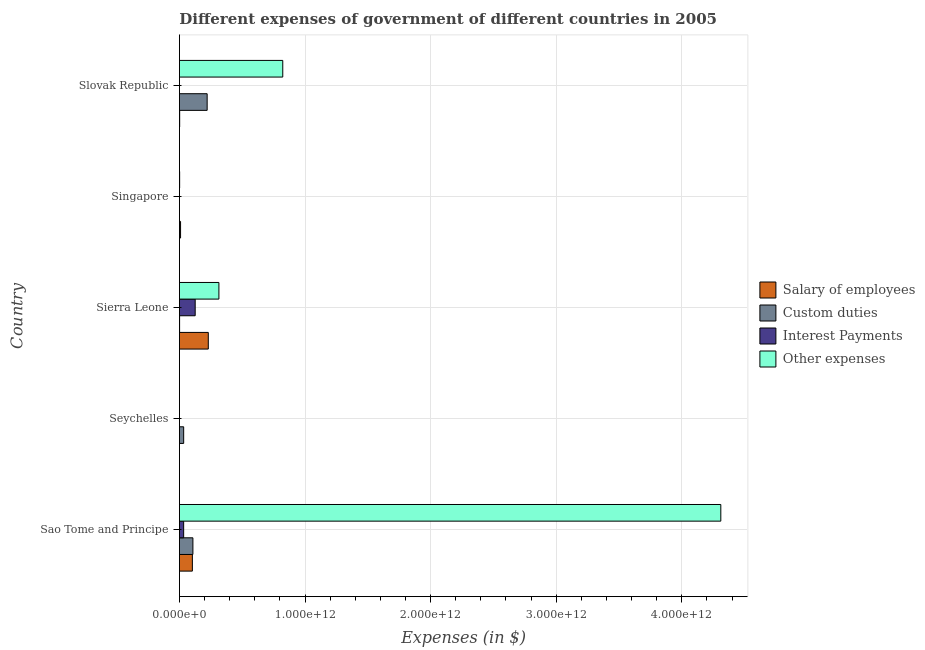How many groups of bars are there?
Offer a terse response. 5. Are the number of bars on each tick of the Y-axis equal?
Give a very brief answer. Yes. How many bars are there on the 1st tick from the top?
Provide a succinct answer. 4. How many bars are there on the 3rd tick from the bottom?
Ensure brevity in your answer.  4. What is the label of the 3rd group of bars from the top?
Offer a terse response. Sierra Leone. What is the amount spent on custom duties in Slovak Republic?
Your response must be concise. 2.21e+11. Across all countries, what is the maximum amount spent on custom duties?
Make the answer very short. 2.21e+11. Across all countries, what is the minimum amount spent on other expenses?
Give a very brief answer. 4.33e+08. In which country was the amount spent on salary of employees maximum?
Provide a succinct answer. Sierra Leone. In which country was the amount spent on interest payments minimum?
Keep it short and to the point. Singapore. What is the total amount spent on interest payments in the graph?
Ensure brevity in your answer.  1.60e+11. What is the difference between the amount spent on interest payments in Seychelles and that in Sierra Leone?
Ensure brevity in your answer.  -1.25e+11. What is the difference between the amount spent on other expenses in Sao Tome and Principe and the amount spent on custom duties in Sierra Leone?
Offer a very short reply. 4.31e+12. What is the average amount spent on salary of employees per country?
Make the answer very short. 6.90e+1. What is the difference between the amount spent on interest payments and amount spent on custom duties in Slovak Republic?
Provide a succinct answer. -2.20e+11. In how many countries, is the amount spent on salary of employees greater than 2200000000000 $?
Provide a succinct answer. 0. What is the ratio of the amount spent on custom duties in Sao Tome and Principe to that in Seychelles?
Offer a very short reply. 3.17. Is the amount spent on interest payments in Sierra Leone less than that in Singapore?
Your response must be concise. No. What is the difference between the highest and the second highest amount spent on other expenses?
Offer a terse response. 3.49e+12. What is the difference between the highest and the lowest amount spent on custom duties?
Keep it short and to the point. 2.20e+11. Is it the case that in every country, the sum of the amount spent on custom duties and amount spent on interest payments is greater than the sum of amount spent on salary of employees and amount spent on other expenses?
Offer a terse response. No. What does the 2nd bar from the top in Sao Tome and Principe represents?
Your answer should be very brief. Interest Payments. What does the 2nd bar from the bottom in Singapore represents?
Offer a very short reply. Custom duties. How many bars are there?
Your answer should be compact. 20. Are all the bars in the graph horizontal?
Your answer should be compact. Yes. How many countries are there in the graph?
Your answer should be very brief. 5. What is the difference between two consecutive major ticks on the X-axis?
Your response must be concise. 1.00e+12. Are the values on the major ticks of X-axis written in scientific E-notation?
Give a very brief answer. Yes. What is the title of the graph?
Provide a succinct answer. Different expenses of government of different countries in 2005. What is the label or title of the X-axis?
Provide a succinct answer. Expenses (in $). What is the Expenses (in $) of Salary of employees in Sao Tome and Principe?
Your answer should be compact. 1.03e+11. What is the Expenses (in $) of Custom duties in Sao Tome and Principe?
Your response must be concise. 1.07e+11. What is the Expenses (in $) of Interest Payments in Sao Tome and Principe?
Offer a terse response. 3.37e+1. What is the Expenses (in $) in Other expenses in Sao Tome and Principe?
Your answer should be very brief. 4.31e+12. What is the Expenses (in $) of Salary of employees in Seychelles?
Your answer should be very brief. 6.81e+08. What is the Expenses (in $) of Custom duties in Seychelles?
Provide a short and direct response. 3.39e+1. What is the Expenses (in $) in Interest Payments in Seychelles?
Make the answer very short. 2.60e+08. What is the Expenses (in $) of Other expenses in Seychelles?
Give a very brief answer. 4.33e+08. What is the Expenses (in $) in Salary of employees in Sierra Leone?
Give a very brief answer. 2.30e+11. What is the Expenses (in $) in Custom duties in Sierra Leone?
Your answer should be compact. 1.47e+09. What is the Expenses (in $) of Interest Payments in Sierra Leone?
Your answer should be compact. 1.26e+11. What is the Expenses (in $) of Other expenses in Sierra Leone?
Provide a succinct answer. 3.14e+11. What is the Expenses (in $) of Salary of employees in Singapore?
Offer a very short reply. 9.11e+09. What is the Expenses (in $) in Custom duties in Singapore?
Your answer should be very brief. 7.28e+08. What is the Expenses (in $) of Interest Payments in Singapore?
Your answer should be compact. 2.03e+08. What is the Expenses (in $) in Other expenses in Singapore?
Provide a short and direct response. 1.83e+09. What is the Expenses (in $) of Salary of employees in Slovak Republic?
Your answer should be compact. 2.10e+09. What is the Expenses (in $) in Custom duties in Slovak Republic?
Make the answer very short. 2.21e+11. What is the Expenses (in $) of Interest Payments in Slovak Republic?
Give a very brief answer. 7.00e+08. What is the Expenses (in $) of Other expenses in Slovak Republic?
Offer a terse response. 8.23e+11. Across all countries, what is the maximum Expenses (in $) in Salary of employees?
Offer a terse response. 2.30e+11. Across all countries, what is the maximum Expenses (in $) of Custom duties?
Make the answer very short. 2.21e+11. Across all countries, what is the maximum Expenses (in $) of Interest Payments?
Offer a terse response. 1.26e+11. Across all countries, what is the maximum Expenses (in $) in Other expenses?
Your response must be concise. 4.31e+12. Across all countries, what is the minimum Expenses (in $) of Salary of employees?
Keep it short and to the point. 6.81e+08. Across all countries, what is the minimum Expenses (in $) in Custom duties?
Your answer should be compact. 7.28e+08. Across all countries, what is the minimum Expenses (in $) of Interest Payments?
Give a very brief answer. 2.03e+08. Across all countries, what is the minimum Expenses (in $) of Other expenses?
Offer a very short reply. 4.33e+08. What is the total Expenses (in $) in Salary of employees in the graph?
Offer a terse response. 3.45e+11. What is the total Expenses (in $) of Custom duties in the graph?
Offer a very short reply. 3.64e+11. What is the total Expenses (in $) of Interest Payments in the graph?
Keep it short and to the point. 1.60e+11. What is the total Expenses (in $) in Other expenses in the graph?
Keep it short and to the point. 5.45e+12. What is the difference between the Expenses (in $) of Salary of employees in Sao Tome and Principe and that in Seychelles?
Provide a short and direct response. 1.03e+11. What is the difference between the Expenses (in $) in Custom duties in Sao Tome and Principe and that in Seychelles?
Give a very brief answer. 7.35e+1. What is the difference between the Expenses (in $) in Interest Payments in Sao Tome and Principe and that in Seychelles?
Offer a very short reply. 3.35e+1. What is the difference between the Expenses (in $) in Other expenses in Sao Tome and Principe and that in Seychelles?
Your answer should be compact. 4.31e+12. What is the difference between the Expenses (in $) of Salary of employees in Sao Tome and Principe and that in Sierra Leone?
Make the answer very short. -1.27e+11. What is the difference between the Expenses (in $) of Custom duties in Sao Tome and Principe and that in Sierra Leone?
Provide a succinct answer. 1.06e+11. What is the difference between the Expenses (in $) of Interest Payments in Sao Tome and Principe and that in Sierra Leone?
Your answer should be very brief. -9.19e+1. What is the difference between the Expenses (in $) in Other expenses in Sao Tome and Principe and that in Sierra Leone?
Offer a terse response. 4.00e+12. What is the difference between the Expenses (in $) of Salary of employees in Sao Tome and Principe and that in Singapore?
Your answer should be compact. 9.41e+1. What is the difference between the Expenses (in $) of Custom duties in Sao Tome and Principe and that in Singapore?
Your answer should be very brief. 1.07e+11. What is the difference between the Expenses (in $) of Interest Payments in Sao Tome and Principe and that in Singapore?
Provide a succinct answer. 3.35e+1. What is the difference between the Expenses (in $) in Other expenses in Sao Tome and Principe and that in Singapore?
Your answer should be very brief. 4.31e+12. What is the difference between the Expenses (in $) of Salary of employees in Sao Tome and Principe and that in Slovak Republic?
Your answer should be very brief. 1.01e+11. What is the difference between the Expenses (in $) in Custom duties in Sao Tome and Principe and that in Slovak Republic?
Keep it short and to the point. -1.13e+11. What is the difference between the Expenses (in $) of Interest Payments in Sao Tome and Principe and that in Slovak Republic?
Make the answer very short. 3.30e+1. What is the difference between the Expenses (in $) in Other expenses in Sao Tome and Principe and that in Slovak Republic?
Your answer should be very brief. 3.49e+12. What is the difference between the Expenses (in $) of Salary of employees in Seychelles and that in Sierra Leone?
Offer a terse response. -2.29e+11. What is the difference between the Expenses (in $) of Custom duties in Seychelles and that in Sierra Leone?
Your response must be concise. 3.24e+1. What is the difference between the Expenses (in $) of Interest Payments in Seychelles and that in Sierra Leone?
Offer a terse response. -1.25e+11. What is the difference between the Expenses (in $) of Other expenses in Seychelles and that in Sierra Leone?
Provide a succinct answer. -3.14e+11. What is the difference between the Expenses (in $) in Salary of employees in Seychelles and that in Singapore?
Your answer should be very brief. -8.43e+09. What is the difference between the Expenses (in $) in Custom duties in Seychelles and that in Singapore?
Offer a terse response. 3.32e+1. What is the difference between the Expenses (in $) in Interest Payments in Seychelles and that in Singapore?
Offer a very short reply. 5.73e+07. What is the difference between the Expenses (in $) of Other expenses in Seychelles and that in Singapore?
Make the answer very short. -1.40e+09. What is the difference between the Expenses (in $) of Salary of employees in Seychelles and that in Slovak Republic?
Your response must be concise. -1.42e+09. What is the difference between the Expenses (in $) in Custom duties in Seychelles and that in Slovak Republic?
Your response must be concise. -1.87e+11. What is the difference between the Expenses (in $) in Interest Payments in Seychelles and that in Slovak Republic?
Make the answer very short. -4.40e+08. What is the difference between the Expenses (in $) in Other expenses in Seychelles and that in Slovak Republic?
Offer a very short reply. -8.23e+11. What is the difference between the Expenses (in $) in Salary of employees in Sierra Leone and that in Singapore?
Offer a very short reply. 2.21e+11. What is the difference between the Expenses (in $) in Custom duties in Sierra Leone and that in Singapore?
Provide a succinct answer. 7.46e+08. What is the difference between the Expenses (in $) in Interest Payments in Sierra Leone and that in Singapore?
Keep it short and to the point. 1.25e+11. What is the difference between the Expenses (in $) in Other expenses in Sierra Leone and that in Singapore?
Your answer should be very brief. 3.13e+11. What is the difference between the Expenses (in $) in Salary of employees in Sierra Leone and that in Slovak Republic?
Ensure brevity in your answer.  2.28e+11. What is the difference between the Expenses (in $) in Custom duties in Sierra Leone and that in Slovak Republic?
Ensure brevity in your answer.  -2.19e+11. What is the difference between the Expenses (in $) of Interest Payments in Sierra Leone and that in Slovak Republic?
Ensure brevity in your answer.  1.25e+11. What is the difference between the Expenses (in $) of Other expenses in Sierra Leone and that in Slovak Republic?
Provide a short and direct response. -5.09e+11. What is the difference between the Expenses (in $) of Salary of employees in Singapore and that in Slovak Republic?
Offer a terse response. 7.01e+09. What is the difference between the Expenses (in $) of Custom duties in Singapore and that in Slovak Republic?
Your answer should be very brief. -2.20e+11. What is the difference between the Expenses (in $) of Interest Payments in Singapore and that in Slovak Republic?
Give a very brief answer. -4.97e+08. What is the difference between the Expenses (in $) in Other expenses in Singapore and that in Slovak Republic?
Provide a short and direct response. -8.21e+11. What is the difference between the Expenses (in $) in Salary of employees in Sao Tome and Principe and the Expenses (in $) in Custom duties in Seychelles?
Your answer should be very brief. 6.93e+1. What is the difference between the Expenses (in $) in Salary of employees in Sao Tome and Principe and the Expenses (in $) in Interest Payments in Seychelles?
Offer a terse response. 1.03e+11. What is the difference between the Expenses (in $) in Salary of employees in Sao Tome and Principe and the Expenses (in $) in Other expenses in Seychelles?
Your answer should be very brief. 1.03e+11. What is the difference between the Expenses (in $) of Custom duties in Sao Tome and Principe and the Expenses (in $) of Interest Payments in Seychelles?
Provide a short and direct response. 1.07e+11. What is the difference between the Expenses (in $) of Custom duties in Sao Tome and Principe and the Expenses (in $) of Other expenses in Seychelles?
Offer a terse response. 1.07e+11. What is the difference between the Expenses (in $) in Interest Payments in Sao Tome and Principe and the Expenses (in $) in Other expenses in Seychelles?
Your response must be concise. 3.33e+1. What is the difference between the Expenses (in $) in Salary of employees in Sao Tome and Principe and the Expenses (in $) in Custom duties in Sierra Leone?
Make the answer very short. 1.02e+11. What is the difference between the Expenses (in $) in Salary of employees in Sao Tome and Principe and the Expenses (in $) in Interest Payments in Sierra Leone?
Give a very brief answer. -2.24e+1. What is the difference between the Expenses (in $) of Salary of employees in Sao Tome and Principe and the Expenses (in $) of Other expenses in Sierra Leone?
Offer a terse response. -2.11e+11. What is the difference between the Expenses (in $) of Custom duties in Sao Tome and Principe and the Expenses (in $) of Interest Payments in Sierra Leone?
Your answer should be compact. -1.82e+1. What is the difference between the Expenses (in $) of Custom duties in Sao Tome and Principe and the Expenses (in $) of Other expenses in Sierra Leone?
Your answer should be very brief. -2.07e+11. What is the difference between the Expenses (in $) in Interest Payments in Sao Tome and Principe and the Expenses (in $) in Other expenses in Sierra Leone?
Offer a terse response. -2.81e+11. What is the difference between the Expenses (in $) of Salary of employees in Sao Tome and Principe and the Expenses (in $) of Custom duties in Singapore?
Ensure brevity in your answer.  1.02e+11. What is the difference between the Expenses (in $) of Salary of employees in Sao Tome and Principe and the Expenses (in $) of Interest Payments in Singapore?
Provide a short and direct response. 1.03e+11. What is the difference between the Expenses (in $) of Salary of employees in Sao Tome and Principe and the Expenses (in $) of Other expenses in Singapore?
Your answer should be very brief. 1.01e+11. What is the difference between the Expenses (in $) in Custom duties in Sao Tome and Principe and the Expenses (in $) in Interest Payments in Singapore?
Provide a short and direct response. 1.07e+11. What is the difference between the Expenses (in $) in Custom duties in Sao Tome and Principe and the Expenses (in $) in Other expenses in Singapore?
Give a very brief answer. 1.06e+11. What is the difference between the Expenses (in $) in Interest Payments in Sao Tome and Principe and the Expenses (in $) in Other expenses in Singapore?
Give a very brief answer. 3.19e+1. What is the difference between the Expenses (in $) in Salary of employees in Sao Tome and Principe and the Expenses (in $) in Custom duties in Slovak Republic?
Provide a short and direct response. -1.18e+11. What is the difference between the Expenses (in $) of Salary of employees in Sao Tome and Principe and the Expenses (in $) of Interest Payments in Slovak Republic?
Ensure brevity in your answer.  1.03e+11. What is the difference between the Expenses (in $) in Salary of employees in Sao Tome and Principe and the Expenses (in $) in Other expenses in Slovak Republic?
Offer a terse response. -7.20e+11. What is the difference between the Expenses (in $) of Custom duties in Sao Tome and Principe and the Expenses (in $) of Interest Payments in Slovak Republic?
Offer a very short reply. 1.07e+11. What is the difference between the Expenses (in $) of Custom duties in Sao Tome and Principe and the Expenses (in $) of Other expenses in Slovak Republic?
Offer a terse response. -7.16e+11. What is the difference between the Expenses (in $) of Interest Payments in Sao Tome and Principe and the Expenses (in $) of Other expenses in Slovak Republic?
Offer a terse response. -7.89e+11. What is the difference between the Expenses (in $) of Salary of employees in Seychelles and the Expenses (in $) of Custom duties in Sierra Leone?
Your response must be concise. -7.93e+08. What is the difference between the Expenses (in $) in Salary of employees in Seychelles and the Expenses (in $) in Interest Payments in Sierra Leone?
Provide a short and direct response. -1.25e+11. What is the difference between the Expenses (in $) of Salary of employees in Seychelles and the Expenses (in $) of Other expenses in Sierra Leone?
Your answer should be very brief. -3.14e+11. What is the difference between the Expenses (in $) of Custom duties in Seychelles and the Expenses (in $) of Interest Payments in Sierra Leone?
Make the answer very short. -9.17e+1. What is the difference between the Expenses (in $) of Custom duties in Seychelles and the Expenses (in $) of Other expenses in Sierra Leone?
Offer a terse response. -2.81e+11. What is the difference between the Expenses (in $) of Interest Payments in Seychelles and the Expenses (in $) of Other expenses in Sierra Leone?
Provide a short and direct response. -3.14e+11. What is the difference between the Expenses (in $) of Salary of employees in Seychelles and the Expenses (in $) of Custom duties in Singapore?
Make the answer very short. -4.69e+07. What is the difference between the Expenses (in $) in Salary of employees in Seychelles and the Expenses (in $) in Interest Payments in Singapore?
Provide a short and direct response. 4.78e+08. What is the difference between the Expenses (in $) of Salary of employees in Seychelles and the Expenses (in $) of Other expenses in Singapore?
Your response must be concise. -1.15e+09. What is the difference between the Expenses (in $) of Custom duties in Seychelles and the Expenses (in $) of Interest Payments in Singapore?
Give a very brief answer. 3.37e+1. What is the difference between the Expenses (in $) in Custom duties in Seychelles and the Expenses (in $) in Other expenses in Singapore?
Your response must be concise. 3.20e+1. What is the difference between the Expenses (in $) of Interest Payments in Seychelles and the Expenses (in $) of Other expenses in Singapore?
Provide a short and direct response. -1.57e+09. What is the difference between the Expenses (in $) of Salary of employees in Seychelles and the Expenses (in $) of Custom duties in Slovak Republic?
Give a very brief answer. -2.20e+11. What is the difference between the Expenses (in $) of Salary of employees in Seychelles and the Expenses (in $) of Interest Payments in Slovak Republic?
Offer a terse response. -1.92e+07. What is the difference between the Expenses (in $) in Salary of employees in Seychelles and the Expenses (in $) in Other expenses in Slovak Republic?
Offer a very short reply. -8.22e+11. What is the difference between the Expenses (in $) of Custom duties in Seychelles and the Expenses (in $) of Interest Payments in Slovak Republic?
Give a very brief answer. 3.32e+1. What is the difference between the Expenses (in $) in Custom duties in Seychelles and the Expenses (in $) in Other expenses in Slovak Republic?
Your answer should be very brief. -7.89e+11. What is the difference between the Expenses (in $) of Interest Payments in Seychelles and the Expenses (in $) of Other expenses in Slovak Republic?
Offer a terse response. -8.23e+11. What is the difference between the Expenses (in $) in Salary of employees in Sierra Leone and the Expenses (in $) in Custom duties in Singapore?
Your answer should be very brief. 2.29e+11. What is the difference between the Expenses (in $) of Salary of employees in Sierra Leone and the Expenses (in $) of Interest Payments in Singapore?
Your response must be concise. 2.30e+11. What is the difference between the Expenses (in $) in Salary of employees in Sierra Leone and the Expenses (in $) in Other expenses in Singapore?
Your answer should be compact. 2.28e+11. What is the difference between the Expenses (in $) in Custom duties in Sierra Leone and the Expenses (in $) in Interest Payments in Singapore?
Keep it short and to the point. 1.27e+09. What is the difference between the Expenses (in $) of Custom duties in Sierra Leone and the Expenses (in $) of Other expenses in Singapore?
Your answer should be compact. -3.60e+08. What is the difference between the Expenses (in $) in Interest Payments in Sierra Leone and the Expenses (in $) in Other expenses in Singapore?
Ensure brevity in your answer.  1.24e+11. What is the difference between the Expenses (in $) of Salary of employees in Sierra Leone and the Expenses (in $) of Custom duties in Slovak Republic?
Keep it short and to the point. 9.07e+09. What is the difference between the Expenses (in $) in Salary of employees in Sierra Leone and the Expenses (in $) in Interest Payments in Slovak Republic?
Ensure brevity in your answer.  2.29e+11. What is the difference between the Expenses (in $) of Salary of employees in Sierra Leone and the Expenses (in $) of Other expenses in Slovak Republic?
Offer a terse response. -5.93e+11. What is the difference between the Expenses (in $) in Custom duties in Sierra Leone and the Expenses (in $) in Interest Payments in Slovak Republic?
Provide a succinct answer. 7.74e+08. What is the difference between the Expenses (in $) of Custom duties in Sierra Leone and the Expenses (in $) of Other expenses in Slovak Republic?
Provide a succinct answer. -8.21e+11. What is the difference between the Expenses (in $) in Interest Payments in Sierra Leone and the Expenses (in $) in Other expenses in Slovak Republic?
Provide a succinct answer. -6.97e+11. What is the difference between the Expenses (in $) in Salary of employees in Singapore and the Expenses (in $) in Custom duties in Slovak Republic?
Offer a very short reply. -2.12e+11. What is the difference between the Expenses (in $) in Salary of employees in Singapore and the Expenses (in $) in Interest Payments in Slovak Republic?
Offer a very short reply. 8.41e+09. What is the difference between the Expenses (in $) of Salary of employees in Singapore and the Expenses (in $) of Other expenses in Slovak Republic?
Offer a terse response. -8.14e+11. What is the difference between the Expenses (in $) in Custom duties in Singapore and the Expenses (in $) in Interest Payments in Slovak Republic?
Provide a short and direct response. 2.78e+07. What is the difference between the Expenses (in $) of Custom duties in Singapore and the Expenses (in $) of Other expenses in Slovak Republic?
Provide a short and direct response. -8.22e+11. What is the difference between the Expenses (in $) of Interest Payments in Singapore and the Expenses (in $) of Other expenses in Slovak Republic?
Keep it short and to the point. -8.23e+11. What is the average Expenses (in $) in Salary of employees per country?
Give a very brief answer. 6.90e+1. What is the average Expenses (in $) in Custom duties per country?
Provide a short and direct response. 7.29e+1. What is the average Expenses (in $) in Interest Payments per country?
Provide a short and direct response. 3.21e+1. What is the average Expenses (in $) of Other expenses per country?
Your answer should be very brief. 1.09e+12. What is the difference between the Expenses (in $) in Salary of employees and Expenses (in $) in Custom duties in Sao Tome and Principe?
Your answer should be very brief. -4.19e+09. What is the difference between the Expenses (in $) in Salary of employees and Expenses (in $) in Interest Payments in Sao Tome and Principe?
Give a very brief answer. 6.95e+1. What is the difference between the Expenses (in $) in Salary of employees and Expenses (in $) in Other expenses in Sao Tome and Principe?
Offer a terse response. -4.21e+12. What is the difference between the Expenses (in $) of Custom duties and Expenses (in $) of Interest Payments in Sao Tome and Principe?
Provide a short and direct response. 7.37e+1. What is the difference between the Expenses (in $) in Custom duties and Expenses (in $) in Other expenses in Sao Tome and Principe?
Make the answer very short. -4.20e+12. What is the difference between the Expenses (in $) in Interest Payments and Expenses (in $) in Other expenses in Sao Tome and Principe?
Give a very brief answer. -4.28e+12. What is the difference between the Expenses (in $) of Salary of employees and Expenses (in $) of Custom duties in Seychelles?
Provide a succinct answer. -3.32e+1. What is the difference between the Expenses (in $) in Salary of employees and Expenses (in $) in Interest Payments in Seychelles?
Make the answer very short. 4.20e+08. What is the difference between the Expenses (in $) in Salary of employees and Expenses (in $) in Other expenses in Seychelles?
Make the answer very short. 2.48e+08. What is the difference between the Expenses (in $) of Custom duties and Expenses (in $) of Interest Payments in Seychelles?
Give a very brief answer. 3.36e+1. What is the difference between the Expenses (in $) of Custom duties and Expenses (in $) of Other expenses in Seychelles?
Give a very brief answer. 3.34e+1. What is the difference between the Expenses (in $) of Interest Payments and Expenses (in $) of Other expenses in Seychelles?
Offer a very short reply. -1.73e+08. What is the difference between the Expenses (in $) of Salary of employees and Expenses (in $) of Custom duties in Sierra Leone?
Provide a succinct answer. 2.28e+11. What is the difference between the Expenses (in $) of Salary of employees and Expenses (in $) of Interest Payments in Sierra Leone?
Offer a very short reply. 1.04e+11. What is the difference between the Expenses (in $) of Salary of employees and Expenses (in $) of Other expenses in Sierra Leone?
Ensure brevity in your answer.  -8.45e+1. What is the difference between the Expenses (in $) of Custom duties and Expenses (in $) of Interest Payments in Sierra Leone?
Make the answer very short. -1.24e+11. What is the difference between the Expenses (in $) of Custom duties and Expenses (in $) of Other expenses in Sierra Leone?
Offer a very short reply. -3.13e+11. What is the difference between the Expenses (in $) of Interest Payments and Expenses (in $) of Other expenses in Sierra Leone?
Provide a short and direct response. -1.89e+11. What is the difference between the Expenses (in $) of Salary of employees and Expenses (in $) of Custom duties in Singapore?
Ensure brevity in your answer.  8.38e+09. What is the difference between the Expenses (in $) in Salary of employees and Expenses (in $) in Interest Payments in Singapore?
Give a very brief answer. 8.91e+09. What is the difference between the Expenses (in $) of Salary of employees and Expenses (in $) of Other expenses in Singapore?
Offer a terse response. 7.28e+09. What is the difference between the Expenses (in $) in Custom duties and Expenses (in $) in Interest Payments in Singapore?
Ensure brevity in your answer.  5.25e+08. What is the difference between the Expenses (in $) of Custom duties and Expenses (in $) of Other expenses in Singapore?
Keep it short and to the point. -1.11e+09. What is the difference between the Expenses (in $) of Interest Payments and Expenses (in $) of Other expenses in Singapore?
Offer a terse response. -1.63e+09. What is the difference between the Expenses (in $) of Salary of employees and Expenses (in $) of Custom duties in Slovak Republic?
Offer a terse response. -2.19e+11. What is the difference between the Expenses (in $) in Salary of employees and Expenses (in $) in Interest Payments in Slovak Republic?
Keep it short and to the point. 1.40e+09. What is the difference between the Expenses (in $) of Salary of employees and Expenses (in $) of Other expenses in Slovak Republic?
Offer a very short reply. -8.21e+11. What is the difference between the Expenses (in $) in Custom duties and Expenses (in $) in Interest Payments in Slovak Republic?
Provide a short and direct response. 2.20e+11. What is the difference between the Expenses (in $) in Custom duties and Expenses (in $) in Other expenses in Slovak Republic?
Provide a succinct answer. -6.02e+11. What is the difference between the Expenses (in $) in Interest Payments and Expenses (in $) in Other expenses in Slovak Republic?
Your answer should be compact. -8.22e+11. What is the ratio of the Expenses (in $) of Salary of employees in Sao Tome and Principe to that in Seychelles?
Your answer should be compact. 151.6. What is the ratio of the Expenses (in $) in Custom duties in Sao Tome and Principe to that in Seychelles?
Make the answer very short. 3.17. What is the ratio of the Expenses (in $) in Interest Payments in Sao Tome and Principe to that in Seychelles?
Provide a succinct answer. 129.56. What is the ratio of the Expenses (in $) in Other expenses in Sao Tome and Principe to that in Seychelles?
Offer a very short reply. 9953.28. What is the ratio of the Expenses (in $) in Salary of employees in Sao Tome and Principe to that in Sierra Leone?
Make the answer very short. 0.45. What is the ratio of the Expenses (in $) of Custom duties in Sao Tome and Principe to that in Sierra Leone?
Provide a short and direct response. 72.88. What is the ratio of the Expenses (in $) in Interest Payments in Sao Tome and Principe to that in Sierra Leone?
Your answer should be compact. 0.27. What is the ratio of the Expenses (in $) of Other expenses in Sao Tome and Principe to that in Sierra Leone?
Offer a very short reply. 13.71. What is the ratio of the Expenses (in $) in Salary of employees in Sao Tome and Principe to that in Singapore?
Offer a very short reply. 11.33. What is the ratio of the Expenses (in $) of Custom duties in Sao Tome and Principe to that in Singapore?
Your answer should be compact. 147.58. What is the ratio of the Expenses (in $) in Interest Payments in Sao Tome and Principe to that in Singapore?
Offer a very short reply. 166.16. What is the ratio of the Expenses (in $) in Other expenses in Sao Tome and Principe to that in Singapore?
Your response must be concise. 2351.23. What is the ratio of the Expenses (in $) of Salary of employees in Sao Tome and Principe to that in Slovak Republic?
Make the answer very short. 49.04. What is the ratio of the Expenses (in $) in Custom duties in Sao Tome and Principe to that in Slovak Republic?
Provide a short and direct response. 0.49. What is the ratio of the Expenses (in $) of Interest Payments in Sao Tome and Principe to that in Slovak Republic?
Give a very brief answer. 48.19. What is the ratio of the Expenses (in $) in Other expenses in Sao Tome and Principe to that in Slovak Republic?
Offer a terse response. 5.24. What is the ratio of the Expenses (in $) of Salary of employees in Seychelles to that in Sierra Leone?
Ensure brevity in your answer.  0. What is the ratio of the Expenses (in $) in Custom duties in Seychelles to that in Sierra Leone?
Make the answer very short. 22.99. What is the ratio of the Expenses (in $) of Interest Payments in Seychelles to that in Sierra Leone?
Make the answer very short. 0. What is the ratio of the Expenses (in $) of Other expenses in Seychelles to that in Sierra Leone?
Ensure brevity in your answer.  0. What is the ratio of the Expenses (in $) in Salary of employees in Seychelles to that in Singapore?
Your answer should be very brief. 0.07. What is the ratio of the Expenses (in $) in Custom duties in Seychelles to that in Singapore?
Your answer should be very brief. 46.56. What is the ratio of the Expenses (in $) of Interest Payments in Seychelles to that in Singapore?
Keep it short and to the point. 1.28. What is the ratio of the Expenses (in $) of Other expenses in Seychelles to that in Singapore?
Your answer should be very brief. 0.24. What is the ratio of the Expenses (in $) in Salary of employees in Seychelles to that in Slovak Republic?
Offer a terse response. 0.32. What is the ratio of the Expenses (in $) in Custom duties in Seychelles to that in Slovak Republic?
Offer a very short reply. 0.15. What is the ratio of the Expenses (in $) in Interest Payments in Seychelles to that in Slovak Republic?
Provide a short and direct response. 0.37. What is the ratio of the Expenses (in $) in Salary of employees in Sierra Leone to that in Singapore?
Ensure brevity in your answer.  25.24. What is the ratio of the Expenses (in $) in Custom duties in Sierra Leone to that in Singapore?
Offer a very short reply. 2.02. What is the ratio of the Expenses (in $) of Interest Payments in Sierra Leone to that in Singapore?
Your answer should be very brief. 618.66. What is the ratio of the Expenses (in $) of Other expenses in Sierra Leone to that in Singapore?
Provide a short and direct response. 171.5. What is the ratio of the Expenses (in $) of Salary of employees in Sierra Leone to that in Slovak Republic?
Provide a short and direct response. 109.26. What is the ratio of the Expenses (in $) in Custom duties in Sierra Leone to that in Slovak Republic?
Your answer should be compact. 0.01. What is the ratio of the Expenses (in $) in Interest Payments in Sierra Leone to that in Slovak Republic?
Make the answer very short. 179.43. What is the ratio of the Expenses (in $) of Other expenses in Sierra Leone to that in Slovak Republic?
Keep it short and to the point. 0.38. What is the ratio of the Expenses (in $) in Salary of employees in Singapore to that in Slovak Republic?
Your response must be concise. 4.33. What is the ratio of the Expenses (in $) in Custom duties in Singapore to that in Slovak Republic?
Keep it short and to the point. 0. What is the ratio of the Expenses (in $) of Interest Payments in Singapore to that in Slovak Republic?
Offer a terse response. 0.29. What is the ratio of the Expenses (in $) of Other expenses in Singapore to that in Slovak Republic?
Your response must be concise. 0. What is the difference between the highest and the second highest Expenses (in $) in Salary of employees?
Your answer should be compact. 1.27e+11. What is the difference between the highest and the second highest Expenses (in $) of Custom duties?
Your response must be concise. 1.13e+11. What is the difference between the highest and the second highest Expenses (in $) in Interest Payments?
Offer a terse response. 9.19e+1. What is the difference between the highest and the second highest Expenses (in $) of Other expenses?
Provide a short and direct response. 3.49e+12. What is the difference between the highest and the lowest Expenses (in $) in Salary of employees?
Keep it short and to the point. 2.29e+11. What is the difference between the highest and the lowest Expenses (in $) in Custom duties?
Your answer should be very brief. 2.20e+11. What is the difference between the highest and the lowest Expenses (in $) in Interest Payments?
Keep it short and to the point. 1.25e+11. What is the difference between the highest and the lowest Expenses (in $) of Other expenses?
Provide a short and direct response. 4.31e+12. 